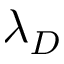Convert formula to latex. <formula><loc_0><loc_0><loc_500><loc_500>\lambda _ { D }</formula> 